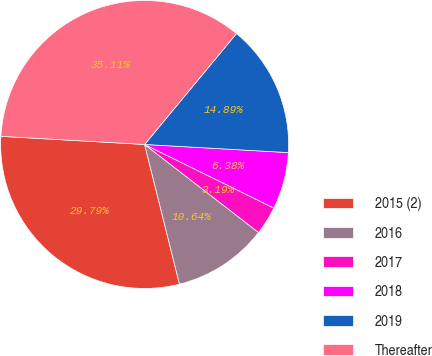Convert chart. <chart><loc_0><loc_0><loc_500><loc_500><pie_chart><fcel>2015 (2)<fcel>2016<fcel>2017<fcel>2018<fcel>2019<fcel>Thereafter<nl><fcel>29.79%<fcel>10.64%<fcel>3.19%<fcel>6.38%<fcel>14.89%<fcel>35.11%<nl></chart> 